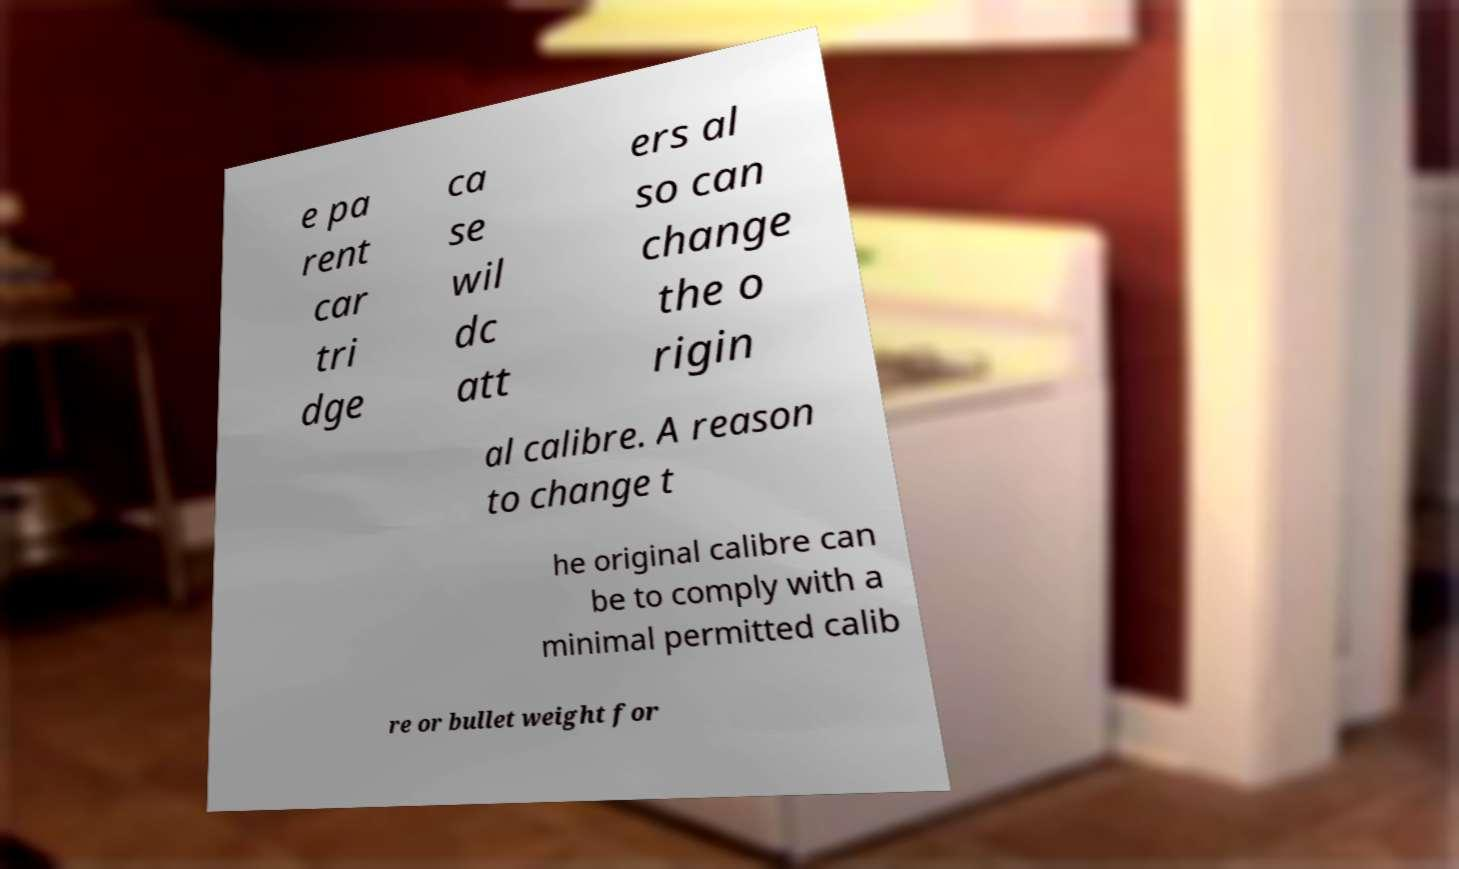Can you accurately transcribe the text from the provided image for me? e pa rent car tri dge ca se wil dc att ers al so can change the o rigin al calibre. A reason to change t he original calibre can be to comply with a minimal permitted calib re or bullet weight for 